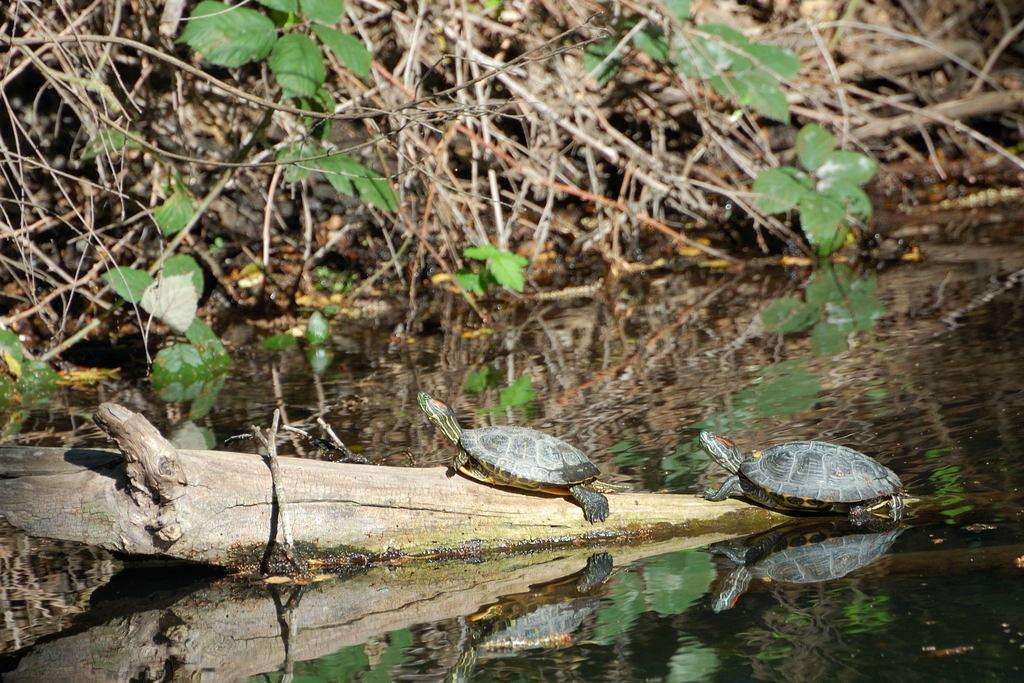How many tortoises are in the image? There are two tortoises in the image. Where are the tortoises located? The tortoises are on a branch of a tree in the image. What color are the tortoises? The tortoises are in ash color. What can be seen in the background of the image? Water, dried sticks, and green leaves are visible in the image. What type of station can be seen in the image? There is no station present in the image; it features two tortoises on a tree branch. What rules are being enforced in the image? There are no rules or enforcement present in the image; it is a natural scene with tortoises and a tree. 